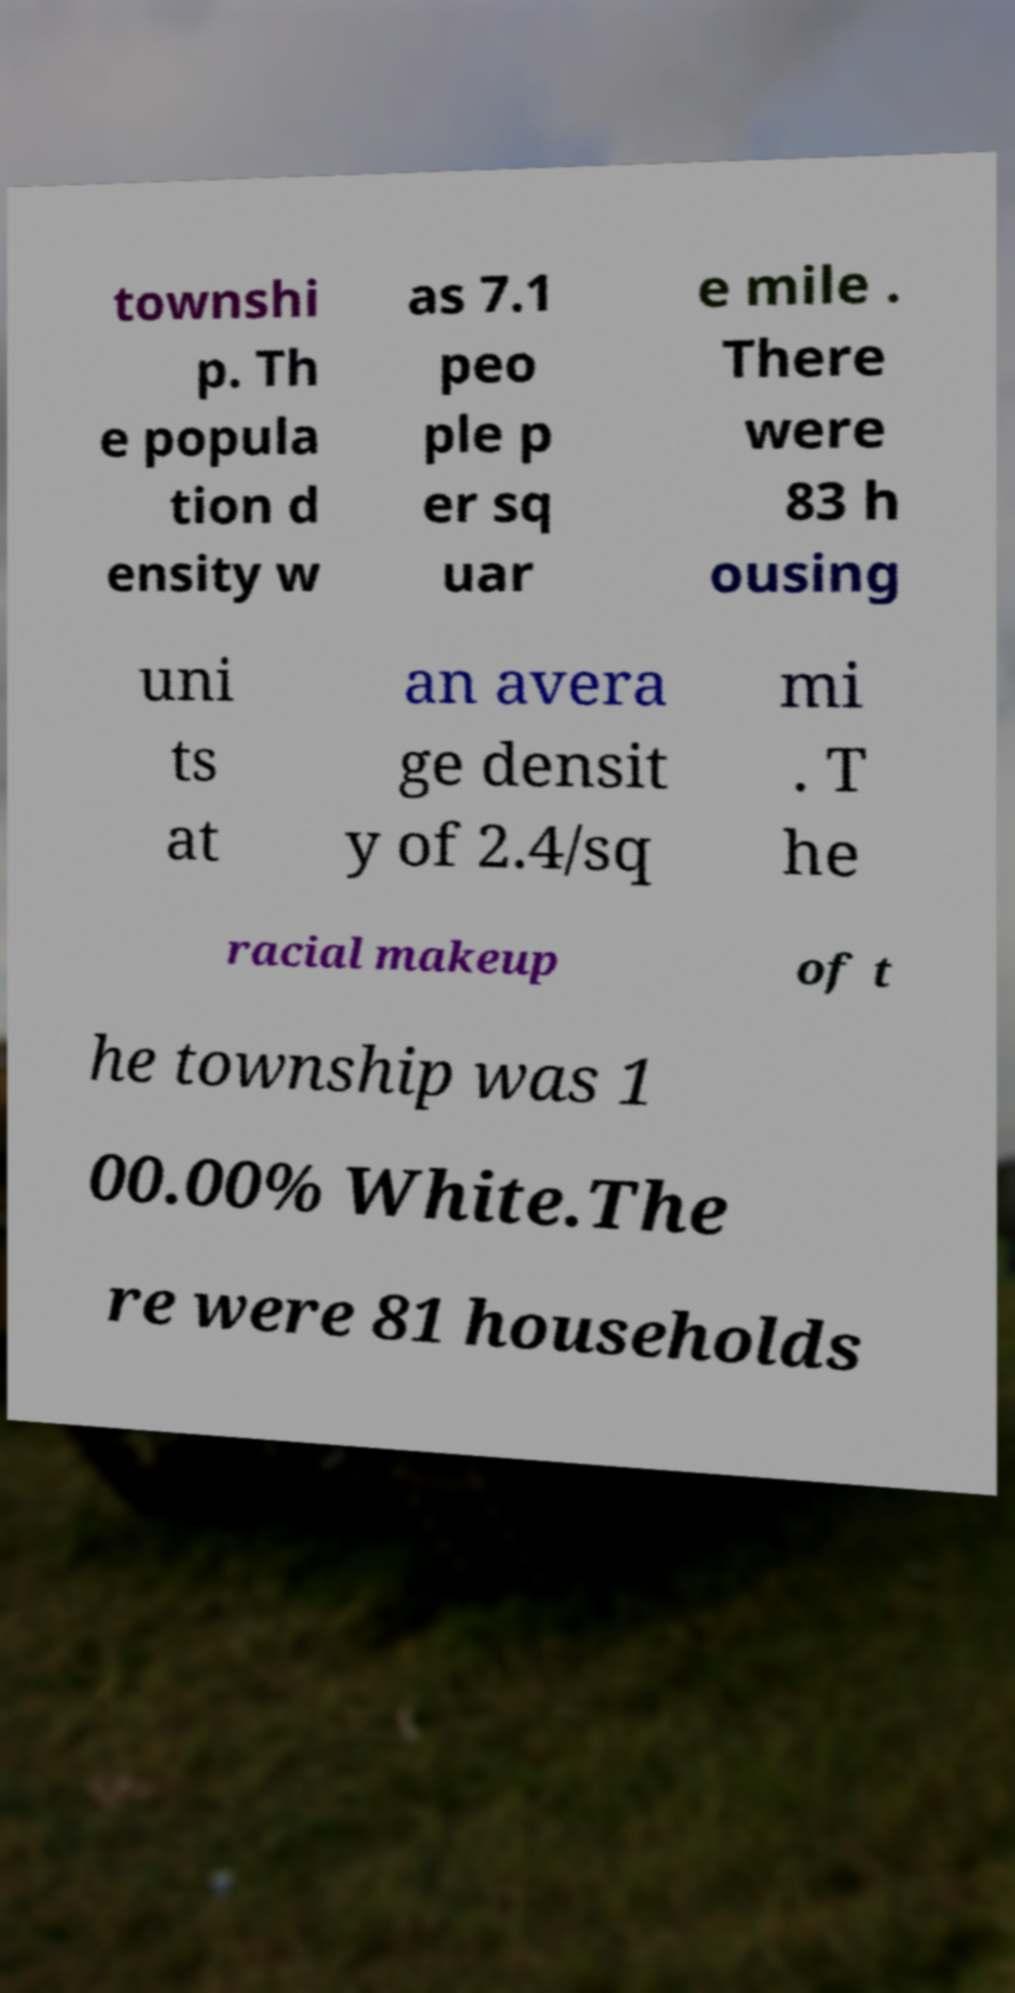Could you extract and type out the text from this image? townshi p. Th e popula tion d ensity w as 7.1 peo ple p er sq uar e mile . There were 83 h ousing uni ts at an avera ge densit y of 2.4/sq mi . T he racial makeup of t he township was 1 00.00% White.The re were 81 households 